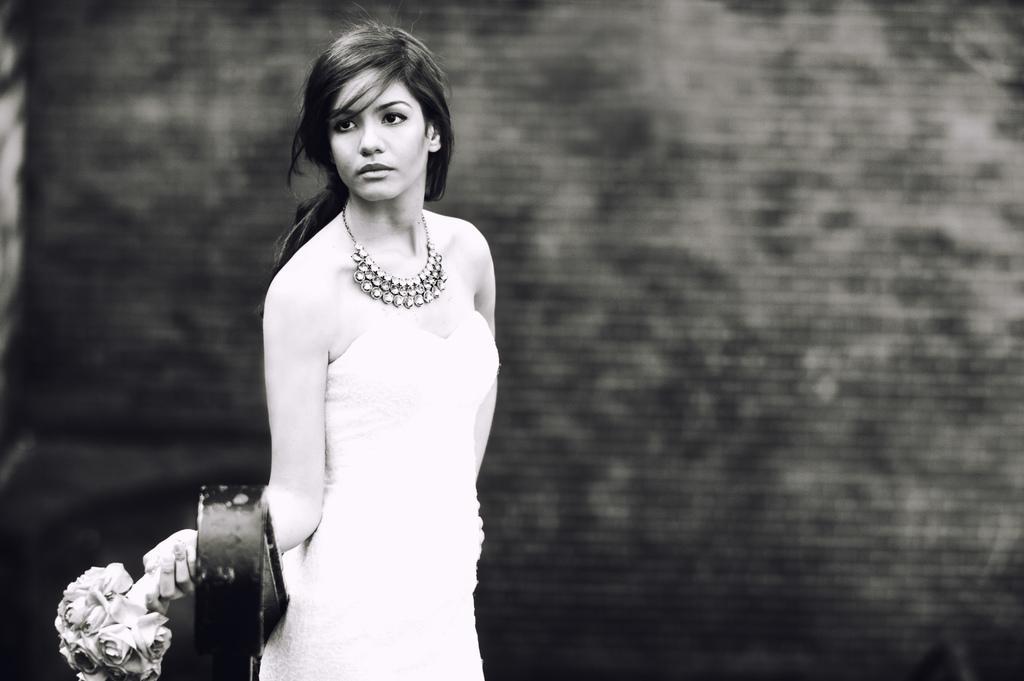Please provide a concise description of this image. This is a black and white image. In this image we can see a woman standing holding a bouquet. 